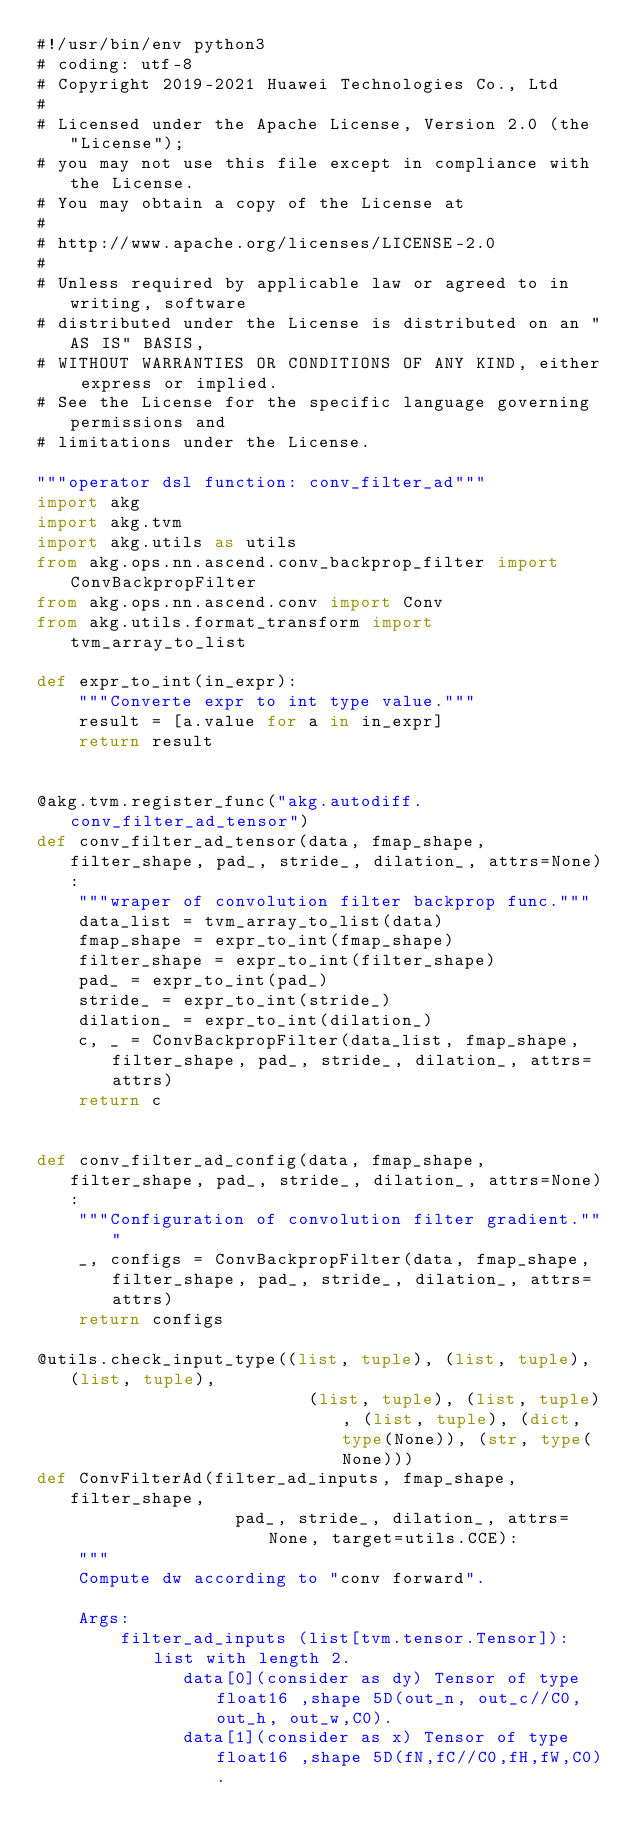<code> <loc_0><loc_0><loc_500><loc_500><_Python_>#!/usr/bin/env python3
# coding: utf-8
# Copyright 2019-2021 Huawei Technologies Co., Ltd
#
# Licensed under the Apache License, Version 2.0 (the "License");
# you may not use this file except in compliance with the License.
# You may obtain a copy of the License at
#
# http://www.apache.org/licenses/LICENSE-2.0
#
# Unless required by applicable law or agreed to in writing, software
# distributed under the License is distributed on an "AS IS" BASIS,
# WITHOUT WARRANTIES OR CONDITIONS OF ANY KIND, either express or implied.
# See the License for the specific language governing permissions and
# limitations under the License.

"""operator dsl function: conv_filter_ad"""
import akg
import akg.tvm
import akg.utils as utils
from akg.ops.nn.ascend.conv_backprop_filter import ConvBackpropFilter
from akg.ops.nn.ascend.conv import Conv
from akg.utils.format_transform import tvm_array_to_list

def expr_to_int(in_expr):
    """Converte expr to int type value."""
    result = [a.value for a in in_expr]
    return result


@akg.tvm.register_func("akg.autodiff.conv_filter_ad_tensor")
def conv_filter_ad_tensor(data, fmap_shape, filter_shape, pad_, stride_, dilation_, attrs=None):
    """wraper of convolution filter backprop func."""
    data_list = tvm_array_to_list(data)
    fmap_shape = expr_to_int(fmap_shape)
    filter_shape = expr_to_int(filter_shape)
    pad_ = expr_to_int(pad_)
    stride_ = expr_to_int(stride_)
    dilation_ = expr_to_int(dilation_)
    c, _ = ConvBackpropFilter(data_list, fmap_shape, filter_shape, pad_, stride_, dilation_, attrs=attrs)
    return c


def conv_filter_ad_config(data, fmap_shape, filter_shape, pad_, stride_, dilation_, attrs=None):
    """Configuration of convolution filter gradient."""
    _, configs = ConvBackpropFilter(data, fmap_shape, filter_shape, pad_, stride_, dilation_, attrs=attrs)
    return configs

@utils.check_input_type((list, tuple), (list, tuple), (list, tuple),
                          (list, tuple), (list, tuple), (list, tuple), (dict, type(None)), (str, type(None)))
def ConvFilterAd(filter_ad_inputs, fmap_shape, filter_shape,
                   pad_, stride_, dilation_, attrs=None, target=utils.CCE):
    """
    Compute dw according to "conv forward".

    Args:
        filter_ad_inputs (list[tvm.tensor.Tensor]): list with length 2.
              data[0](consider as dy) Tensor of type float16 ,shape 5D(out_n, out_c//C0, out_h, out_w,C0).
              data[1](consider as x) Tensor of type float16 ,shape 5D(fN,fC//C0,fH,fW,C0).</code> 